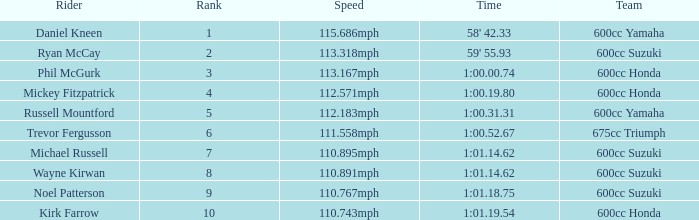How many ranks have 1:01.14.62 as the time, with michael russell as the rider? 1.0. 